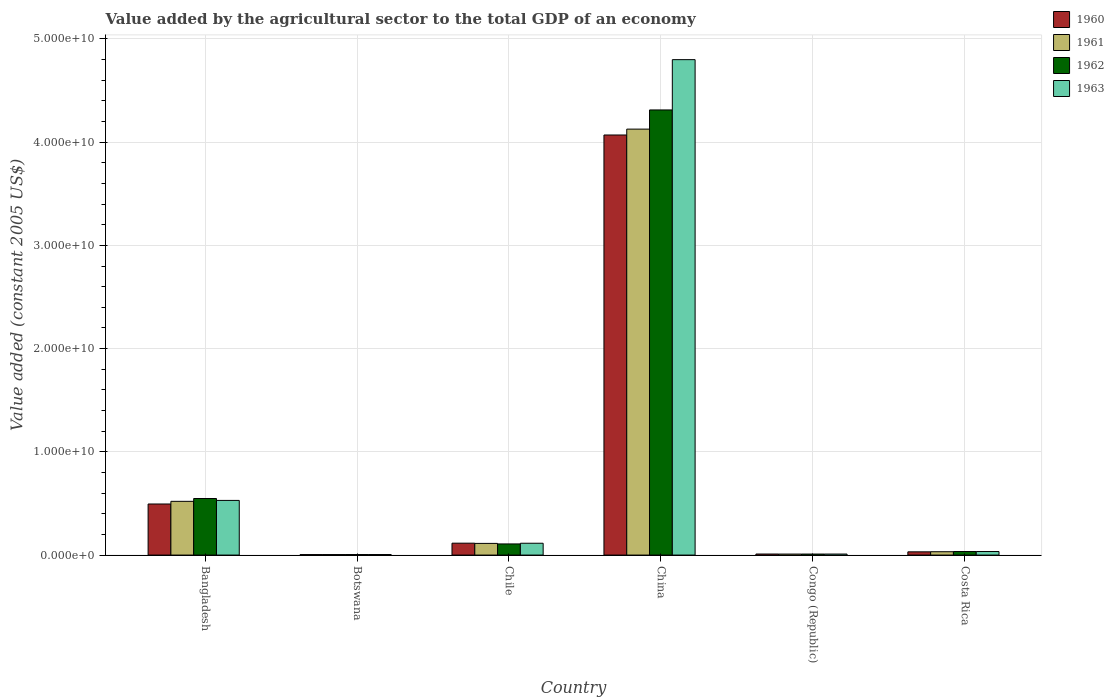How many different coloured bars are there?
Provide a succinct answer. 4. How many groups of bars are there?
Provide a short and direct response. 6. How many bars are there on the 2nd tick from the left?
Offer a terse response. 4. In how many cases, is the number of bars for a given country not equal to the number of legend labels?
Offer a very short reply. 0. What is the value added by the agricultural sector in 1963 in Costa Rica?
Offer a very short reply. 3.43e+08. Across all countries, what is the maximum value added by the agricultural sector in 1961?
Provide a succinct answer. 4.13e+1. Across all countries, what is the minimum value added by the agricultural sector in 1960?
Provide a short and direct response. 4.74e+07. In which country was the value added by the agricultural sector in 1960 maximum?
Give a very brief answer. China. In which country was the value added by the agricultural sector in 1960 minimum?
Ensure brevity in your answer.  Botswana. What is the total value added by the agricultural sector in 1961 in the graph?
Give a very brief answer. 4.81e+1. What is the difference between the value added by the agricultural sector in 1962 in Botswana and that in China?
Keep it short and to the point. -4.31e+1. What is the difference between the value added by the agricultural sector in 1960 in Congo (Republic) and the value added by the agricultural sector in 1961 in Botswana?
Offer a very short reply. 5.23e+07. What is the average value added by the agricultural sector in 1963 per country?
Offer a terse response. 9.16e+09. What is the difference between the value added by the agricultural sector of/in 1961 and value added by the agricultural sector of/in 1962 in China?
Your answer should be compact. -1.86e+09. In how many countries, is the value added by the agricultural sector in 1960 greater than 4000000000 US$?
Give a very brief answer. 2. What is the ratio of the value added by the agricultural sector in 1962 in Bangladesh to that in Chile?
Keep it short and to the point. 5.08. Is the value added by the agricultural sector in 1961 in Botswana less than that in Congo (Republic)?
Give a very brief answer. Yes. What is the difference between the highest and the second highest value added by the agricultural sector in 1961?
Provide a short and direct response. -4.08e+09. What is the difference between the highest and the lowest value added by the agricultural sector in 1963?
Your answer should be compact. 4.79e+1. What does the 2nd bar from the left in Bangladesh represents?
Offer a very short reply. 1961. What does the 4th bar from the right in Congo (Republic) represents?
Provide a succinct answer. 1960. How many bars are there?
Keep it short and to the point. 24. What is the difference between two consecutive major ticks on the Y-axis?
Provide a short and direct response. 1.00e+1. Are the values on the major ticks of Y-axis written in scientific E-notation?
Offer a terse response. Yes. Does the graph contain any zero values?
Your answer should be very brief. No. Does the graph contain grids?
Your answer should be compact. Yes. How are the legend labels stacked?
Make the answer very short. Vertical. What is the title of the graph?
Your answer should be very brief. Value added by the agricultural sector to the total GDP of an economy. What is the label or title of the Y-axis?
Your answer should be compact. Value added (constant 2005 US$). What is the Value added (constant 2005 US$) in 1960 in Bangladesh?
Provide a succinct answer. 4.95e+09. What is the Value added (constant 2005 US$) of 1961 in Bangladesh?
Provide a succinct answer. 5.21e+09. What is the Value added (constant 2005 US$) of 1962 in Bangladesh?
Provide a short and direct response. 5.48e+09. What is the Value added (constant 2005 US$) in 1963 in Bangladesh?
Give a very brief answer. 5.30e+09. What is the Value added (constant 2005 US$) in 1960 in Botswana?
Give a very brief answer. 4.74e+07. What is the Value added (constant 2005 US$) in 1961 in Botswana?
Offer a very short reply. 4.86e+07. What is the Value added (constant 2005 US$) in 1962 in Botswana?
Give a very brief answer. 5.04e+07. What is the Value added (constant 2005 US$) of 1963 in Botswana?
Provide a short and direct response. 5.21e+07. What is the Value added (constant 2005 US$) of 1960 in Chile?
Your answer should be very brief. 1.15e+09. What is the Value added (constant 2005 US$) in 1961 in Chile?
Keep it short and to the point. 1.13e+09. What is the Value added (constant 2005 US$) in 1962 in Chile?
Provide a short and direct response. 1.08e+09. What is the Value added (constant 2005 US$) of 1963 in Chile?
Provide a succinct answer. 1.15e+09. What is the Value added (constant 2005 US$) of 1960 in China?
Offer a very short reply. 4.07e+1. What is the Value added (constant 2005 US$) in 1961 in China?
Offer a very short reply. 4.13e+1. What is the Value added (constant 2005 US$) of 1962 in China?
Give a very brief answer. 4.31e+1. What is the Value added (constant 2005 US$) in 1963 in China?
Offer a very short reply. 4.80e+1. What is the Value added (constant 2005 US$) of 1960 in Congo (Republic)?
Your answer should be very brief. 1.01e+08. What is the Value added (constant 2005 US$) in 1961 in Congo (Republic)?
Ensure brevity in your answer.  9.74e+07. What is the Value added (constant 2005 US$) of 1962 in Congo (Republic)?
Offer a terse response. 9.79e+07. What is the Value added (constant 2005 US$) in 1963 in Congo (Republic)?
Ensure brevity in your answer.  9.86e+07. What is the Value added (constant 2005 US$) in 1960 in Costa Rica?
Offer a very short reply. 3.13e+08. What is the Value added (constant 2005 US$) of 1961 in Costa Rica?
Provide a short and direct response. 3.24e+08. What is the Value added (constant 2005 US$) in 1962 in Costa Rica?
Your response must be concise. 3.44e+08. What is the Value added (constant 2005 US$) in 1963 in Costa Rica?
Your answer should be compact. 3.43e+08. Across all countries, what is the maximum Value added (constant 2005 US$) in 1960?
Offer a terse response. 4.07e+1. Across all countries, what is the maximum Value added (constant 2005 US$) of 1961?
Provide a succinct answer. 4.13e+1. Across all countries, what is the maximum Value added (constant 2005 US$) in 1962?
Provide a short and direct response. 4.31e+1. Across all countries, what is the maximum Value added (constant 2005 US$) in 1963?
Offer a terse response. 4.80e+1. Across all countries, what is the minimum Value added (constant 2005 US$) of 1960?
Your answer should be very brief. 4.74e+07. Across all countries, what is the minimum Value added (constant 2005 US$) in 1961?
Your answer should be compact. 4.86e+07. Across all countries, what is the minimum Value added (constant 2005 US$) of 1962?
Ensure brevity in your answer.  5.04e+07. Across all countries, what is the minimum Value added (constant 2005 US$) of 1963?
Make the answer very short. 5.21e+07. What is the total Value added (constant 2005 US$) in 1960 in the graph?
Offer a very short reply. 4.73e+1. What is the total Value added (constant 2005 US$) of 1961 in the graph?
Provide a succinct answer. 4.81e+1. What is the total Value added (constant 2005 US$) of 1962 in the graph?
Provide a short and direct response. 5.02e+1. What is the total Value added (constant 2005 US$) in 1963 in the graph?
Your response must be concise. 5.49e+1. What is the difference between the Value added (constant 2005 US$) in 1960 in Bangladesh and that in Botswana?
Provide a short and direct response. 4.90e+09. What is the difference between the Value added (constant 2005 US$) of 1961 in Bangladesh and that in Botswana?
Make the answer very short. 5.16e+09. What is the difference between the Value added (constant 2005 US$) of 1962 in Bangladesh and that in Botswana?
Offer a terse response. 5.43e+09. What is the difference between the Value added (constant 2005 US$) of 1963 in Bangladesh and that in Botswana?
Provide a succinct answer. 5.24e+09. What is the difference between the Value added (constant 2005 US$) of 1960 in Bangladesh and that in Chile?
Your response must be concise. 3.80e+09. What is the difference between the Value added (constant 2005 US$) in 1961 in Bangladesh and that in Chile?
Your answer should be compact. 4.08e+09. What is the difference between the Value added (constant 2005 US$) in 1962 in Bangladesh and that in Chile?
Your answer should be compact. 4.40e+09. What is the difference between the Value added (constant 2005 US$) of 1963 in Bangladesh and that in Chile?
Make the answer very short. 4.15e+09. What is the difference between the Value added (constant 2005 US$) in 1960 in Bangladesh and that in China?
Provide a short and direct response. -3.57e+1. What is the difference between the Value added (constant 2005 US$) of 1961 in Bangladesh and that in China?
Keep it short and to the point. -3.61e+1. What is the difference between the Value added (constant 2005 US$) of 1962 in Bangladesh and that in China?
Your response must be concise. -3.76e+1. What is the difference between the Value added (constant 2005 US$) in 1963 in Bangladesh and that in China?
Give a very brief answer. -4.27e+1. What is the difference between the Value added (constant 2005 US$) in 1960 in Bangladesh and that in Congo (Republic)?
Give a very brief answer. 4.85e+09. What is the difference between the Value added (constant 2005 US$) in 1961 in Bangladesh and that in Congo (Republic)?
Provide a succinct answer. 5.11e+09. What is the difference between the Value added (constant 2005 US$) of 1962 in Bangladesh and that in Congo (Republic)?
Keep it short and to the point. 5.38e+09. What is the difference between the Value added (constant 2005 US$) in 1963 in Bangladesh and that in Congo (Republic)?
Ensure brevity in your answer.  5.20e+09. What is the difference between the Value added (constant 2005 US$) in 1960 in Bangladesh and that in Costa Rica?
Provide a short and direct response. 4.64e+09. What is the difference between the Value added (constant 2005 US$) of 1961 in Bangladesh and that in Costa Rica?
Offer a very short reply. 4.88e+09. What is the difference between the Value added (constant 2005 US$) of 1962 in Bangladesh and that in Costa Rica?
Offer a very short reply. 5.14e+09. What is the difference between the Value added (constant 2005 US$) in 1963 in Bangladesh and that in Costa Rica?
Give a very brief answer. 4.95e+09. What is the difference between the Value added (constant 2005 US$) of 1960 in Botswana and that in Chile?
Your response must be concise. -1.10e+09. What is the difference between the Value added (constant 2005 US$) of 1961 in Botswana and that in Chile?
Your answer should be compact. -1.08e+09. What is the difference between the Value added (constant 2005 US$) of 1962 in Botswana and that in Chile?
Your answer should be compact. -1.03e+09. What is the difference between the Value added (constant 2005 US$) in 1963 in Botswana and that in Chile?
Ensure brevity in your answer.  -1.09e+09. What is the difference between the Value added (constant 2005 US$) of 1960 in Botswana and that in China?
Provide a short and direct response. -4.07e+1. What is the difference between the Value added (constant 2005 US$) of 1961 in Botswana and that in China?
Give a very brief answer. -4.12e+1. What is the difference between the Value added (constant 2005 US$) of 1962 in Botswana and that in China?
Your answer should be compact. -4.31e+1. What is the difference between the Value added (constant 2005 US$) in 1963 in Botswana and that in China?
Your answer should be compact. -4.79e+1. What is the difference between the Value added (constant 2005 US$) in 1960 in Botswana and that in Congo (Republic)?
Give a very brief answer. -5.35e+07. What is the difference between the Value added (constant 2005 US$) in 1961 in Botswana and that in Congo (Republic)?
Provide a succinct answer. -4.87e+07. What is the difference between the Value added (constant 2005 US$) of 1962 in Botswana and that in Congo (Republic)?
Ensure brevity in your answer.  -4.76e+07. What is the difference between the Value added (constant 2005 US$) in 1963 in Botswana and that in Congo (Republic)?
Your answer should be compact. -4.65e+07. What is the difference between the Value added (constant 2005 US$) in 1960 in Botswana and that in Costa Rica?
Make the answer very short. -2.66e+08. What is the difference between the Value added (constant 2005 US$) of 1961 in Botswana and that in Costa Rica?
Provide a short and direct response. -2.76e+08. What is the difference between the Value added (constant 2005 US$) of 1962 in Botswana and that in Costa Rica?
Your answer should be compact. -2.94e+08. What is the difference between the Value added (constant 2005 US$) in 1963 in Botswana and that in Costa Rica?
Keep it short and to the point. -2.91e+08. What is the difference between the Value added (constant 2005 US$) in 1960 in Chile and that in China?
Your response must be concise. -3.95e+1. What is the difference between the Value added (constant 2005 US$) in 1961 in Chile and that in China?
Offer a very short reply. -4.01e+1. What is the difference between the Value added (constant 2005 US$) of 1962 in Chile and that in China?
Provide a short and direct response. -4.20e+1. What is the difference between the Value added (constant 2005 US$) of 1963 in Chile and that in China?
Offer a very short reply. -4.69e+1. What is the difference between the Value added (constant 2005 US$) in 1960 in Chile and that in Congo (Republic)?
Your answer should be very brief. 1.05e+09. What is the difference between the Value added (constant 2005 US$) in 1961 in Chile and that in Congo (Republic)?
Offer a terse response. 1.03e+09. What is the difference between the Value added (constant 2005 US$) of 1962 in Chile and that in Congo (Republic)?
Offer a very short reply. 9.81e+08. What is the difference between the Value added (constant 2005 US$) of 1963 in Chile and that in Congo (Republic)?
Provide a succinct answer. 1.05e+09. What is the difference between the Value added (constant 2005 US$) in 1960 in Chile and that in Costa Rica?
Offer a terse response. 8.39e+08. What is the difference between the Value added (constant 2005 US$) of 1961 in Chile and that in Costa Rica?
Your answer should be compact. 8.06e+08. What is the difference between the Value added (constant 2005 US$) of 1962 in Chile and that in Costa Rica?
Ensure brevity in your answer.  7.35e+08. What is the difference between the Value added (constant 2005 US$) of 1963 in Chile and that in Costa Rica?
Your answer should be very brief. 8.03e+08. What is the difference between the Value added (constant 2005 US$) in 1960 in China and that in Congo (Republic)?
Keep it short and to the point. 4.06e+1. What is the difference between the Value added (constant 2005 US$) of 1961 in China and that in Congo (Republic)?
Offer a terse response. 4.12e+1. What is the difference between the Value added (constant 2005 US$) in 1962 in China and that in Congo (Republic)?
Make the answer very short. 4.30e+1. What is the difference between the Value added (constant 2005 US$) in 1963 in China and that in Congo (Republic)?
Offer a very short reply. 4.79e+1. What is the difference between the Value added (constant 2005 US$) of 1960 in China and that in Costa Rica?
Your response must be concise. 4.04e+1. What is the difference between the Value added (constant 2005 US$) of 1961 in China and that in Costa Rica?
Offer a terse response. 4.09e+1. What is the difference between the Value added (constant 2005 US$) of 1962 in China and that in Costa Rica?
Your answer should be very brief. 4.28e+1. What is the difference between the Value added (constant 2005 US$) in 1963 in China and that in Costa Rica?
Your response must be concise. 4.77e+1. What is the difference between the Value added (constant 2005 US$) in 1960 in Congo (Republic) and that in Costa Rica?
Your answer should be very brief. -2.12e+08. What is the difference between the Value added (constant 2005 US$) in 1961 in Congo (Republic) and that in Costa Rica?
Offer a terse response. -2.27e+08. What is the difference between the Value added (constant 2005 US$) in 1962 in Congo (Republic) and that in Costa Rica?
Your response must be concise. -2.46e+08. What is the difference between the Value added (constant 2005 US$) of 1963 in Congo (Republic) and that in Costa Rica?
Offer a terse response. -2.45e+08. What is the difference between the Value added (constant 2005 US$) of 1960 in Bangladesh and the Value added (constant 2005 US$) of 1961 in Botswana?
Your answer should be compact. 4.90e+09. What is the difference between the Value added (constant 2005 US$) in 1960 in Bangladesh and the Value added (constant 2005 US$) in 1962 in Botswana?
Ensure brevity in your answer.  4.90e+09. What is the difference between the Value added (constant 2005 US$) of 1960 in Bangladesh and the Value added (constant 2005 US$) of 1963 in Botswana?
Keep it short and to the point. 4.90e+09. What is the difference between the Value added (constant 2005 US$) in 1961 in Bangladesh and the Value added (constant 2005 US$) in 1962 in Botswana?
Provide a succinct answer. 5.16e+09. What is the difference between the Value added (constant 2005 US$) in 1961 in Bangladesh and the Value added (constant 2005 US$) in 1963 in Botswana?
Provide a short and direct response. 5.15e+09. What is the difference between the Value added (constant 2005 US$) of 1962 in Bangladesh and the Value added (constant 2005 US$) of 1963 in Botswana?
Your response must be concise. 5.43e+09. What is the difference between the Value added (constant 2005 US$) of 1960 in Bangladesh and the Value added (constant 2005 US$) of 1961 in Chile?
Make the answer very short. 3.82e+09. What is the difference between the Value added (constant 2005 US$) in 1960 in Bangladesh and the Value added (constant 2005 US$) in 1962 in Chile?
Offer a very short reply. 3.87e+09. What is the difference between the Value added (constant 2005 US$) of 1960 in Bangladesh and the Value added (constant 2005 US$) of 1963 in Chile?
Your answer should be very brief. 3.80e+09. What is the difference between the Value added (constant 2005 US$) in 1961 in Bangladesh and the Value added (constant 2005 US$) in 1962 in Chile?
Offer a very short reply. 4.13e+09. What is the difference between the Value added (constant 2005 US$) of 1961 in Bangladesh and the Value added (constant 2005 US$) of 1963 in Chile?
Ensure brevity in your answer.  4.06e+09. What is the difference between the Value added (constant 2005 US$) in 1962 in Bangladesh and the Value added (constant 2005 US$) in 1963 in Chile?
Provide a succinct answer. 4.33e+09. What is the difference between the Value added (constant 2005 US$) in 1960 in Bangladesh and the Value added (constant 2005 US$) in 1961 in China?
Make the answer very short. -3.63e+1. What is the difference between the Value added (constant 2005 US$) of 1960 in Bangladesh and the Value added (constant 2005 US$) of 1962 in China?
Ensure brevity in your answer.  -3.82e+1. What is the difference between the Value added (constant 2005 US$) in 1960 in Bangladesh and the Value added (constant 2005 US$) in 1963 in China?
Offer a very short reply. -4.30e+1. What is the difference between the Value added (constant 2005 US$) in 1961 in Bangladesh and the Value added (constant 2005 US$) in 1962 in China?
Offer a very short reply. -3.79e+1. What is the difference between the Value added (constant 2005 US$) of 1961 in Bangladesh and the Value added (constant 2005 US$) of 1963 in China?
Offer a terse response. -4.28e+1. What is the difference between the Value added (constant 2005 US$) in 1962 in Bangladesh and the Value added (constant 2005 US$) in 1963 in China?
Offer a terse response. -4.25e+1. What is the difference between the Value added (constant 2005 US$) in 1960 in Bangladesh and the Value added (constant 2005 US$) in 1961 in Congo (Republic)?
Ensure brevity in your answer.  4.85e+09. What is the difference between the Value added (constant 2005 US$) in 1960 in Bangladesh and the Value added (constant 2005 US$) in 1962 in Congo (Republic)?
Your response must be concise. 4.85e+09. What is the difference between the Value added (constant 2005 US$) in 1960 in Bangladesh and the Value added (constant 2005 US$) in 1963 in Congo (Republic)?
Provide a succinct answer. 4.85e+09. What is the difference between the Value added (constant 2005 US$) of 1961 in Bangladesh and the Value added (constant 2005 US$) of 1962 in Congo (Republic)?
Your answer should be compact. 5.11e+09. What is the difference between the Value added (constant 2005 US$) of 1961 in Bangladesh and the Value added (constant 2005 US$) of 1963 in Congo (Republic)?
Ensure brevity in your answer.  5.11e+09. What is the difference between the Value added (constant 2005 US$) of 1962 in Bangladesh and the Value added (constant 2005 US$) of 1963 in Congo (Republic)?
Ensure brevity in your answer.  5.38e+09. What is the difference between the Value added (constant 2005 US$) in 1960 in Bangladesh and the Value added (constant 2005 US$) in 1961 in Costa Rica?
Ensure brevity in your answer.  4.62e+09. What is the difference between the Value added (constant 2005 US$) in 1960 in Bangladesh and the Value added (constant 2005 US$) in 1962 in Costa Rica?
Your answer should be very brief. 4.60e+09. What is the difference between the Value added (constant 2005 US$) of 1960 in Bangladesh and the Value added (constant 2005 US$) of 1963 in Costa Rica?
Give a very brief answer. 4.61e+09. What is the difference between the Value added (constant 2005 US$) of 1961 in Bangladesh and the Value added (constant 2005 US$) of 1962 in Costa Rica?
Offer a very short reply. 4.86e+09. What is the difference between the Value added (constant 2005 US$) in 1961 in Bangladesh and the Value added (constant 2005 US$) in 1963 in Costa Rica?
Offer a very short reply. 4.86e+09. What is the difference between the Value added (constant 2005 US$) in 1962 in Bangladesh and the Value added (constant 2005 US$) in 1963 in Costa Rica?
Offer a terse response. 5.14e+09. What is the difference between the Value added (constant 2005 US$) of 1960 in Botswana and the Value added (constant 2005 US$) of 1961 in Chile?
Give a very brief answer. -1.08e+09. What is the difference between the Value added (constant 2005 US$) in 1960 in Botswana and the Value added (constant 2005 US$) in 1962 in Chile?
Ensure brevity in your answer.  -1.03e+09. What is the difference between the Value added (constant 2005 US$) of 1960 in Botswana and the Value added (constant 2005 US$) of 1963 in Chile?
Provide a succinct answer. -1.10e+09. What is the difference between the Value added (constant 2005 US$) in 1961 in Botswana and the Value added (constant 2005 US$) in 1962 in Chile?
Offer a very short reply. -1.03e+09. What is the difference between the Value added (constant 2005 US$) in 1961 in Botswana and the Value added (constant 2005 US$) in 1963 in Chile?
Make the answer very short. -1.10e+09. What is the difference between the Value added (constant 2005 US$) of 1962 in Botswana and the Value added (constant 2005 US$) of 1963 in Chile?
Provide a succinct answer. -1.10e+09. What is the difference between the Value added (constant 2005 US$) of 1960 in Botswana and the Value added (constant 2005 US$) of 1961 in China?
Keep it short and to the point. -4.12e+1. What is the difference between the Value added (constant 2005 US$) of 1960 in Botswana and the Value added (constant 2005 US$) of 1962 in China?
Make the answer very short. -4.31e+1. What is the difference between the Value added (constant 2005 US$) in 1960 in Botswana and the Value added (constant 2005 US$) in 1963 in China?
Your answer should be compact. -4.80e+1. What is the difference between the Value added (constant 2005 US$) of 1961 in Botswana and the Value added (constant 2005 US$) of 1962 in China?
Provide a short and direct response. -4.31e+1. What is the difference between the Value added (constant 2005 US$) in 1961 in Botswana and the Value added (constant 2005 US$) in 1963 in China?
Your answer should be compact. -4.79e+1. What is the difference between the Value added (constant 2005 US$) of 1962 in Botswana and the Value added (constant 2005 US$) of 1963 in China?
Your answer should be compact. -4.79e+1. What is the difference between the Value added (constant 2005 US$) of 1960 in Botswana and the Value added (constant 2005 US$) of 1961 in Congo (Republic)?
Make the answer very short. -4.99e+07. What is the difference between the Value added (constant 2005 US$) of 1960 in Botswana and the Value added (constant 2005 US$) of 1962 in Congo (Republic)?
Your answer should be very brief. -5.05e+07. What is the difference between the Value added (constant 2005 US$) in 1960 in Botswana and the Value added (constant 2005 US$) in 1963 in Congo (Republic)?
Offer a very short reply. -5.12e+07. What is the difference between the Value added (constant 2005 US$) in 1961 in Botswana and the Value added (constant 2005 US$) in 1962 in Congo (Republic)?
Your answer should be compact. -4.93e+07. What is the difference between the Value added (constant 2005 US$) of 1961 in Botswana and the Value added (constant 2005 US$) of 1963 in Congo (Republic)?
Make the answer very short. -5.00e+07. What is the difference between the Value added (constant 2005 US$) of 1962 in Botswana and the Value added (constant 2005 US$) of 1963 in Congo (Republic)?
Ensure brevity in your answer.  -4.83e+07. What is the difference between the Value added (constant 2005 US$) in 1960 in Botswana and the Value added (constant 2005 US$) in 1961 in Costa Rica?
Give a very brief answer. -2.77e+08. What is the difference between the Value added (constant 2005 US$) in 1960 in Botswana and the Value added (constant 2005 US$) in 1962 in Costa Rica?
Give a very brief answer. -2.97e+08. What is the difference between the Value added (constant 2005 US$) in 1960 in Botswana and the Value added (constant 2005 US$) in 1963 in Costa Rica?
Your answer should be very brief. -2.96e+08. What is the difference between the Value added (constant 2005 US$) of 1961 in Botswana and the Value added (constant 2005 US$) of 1962 in Costa Rica?
Provide a succinct answer. -2.96e+08. What is the difference between the Value added (constant 2005 US$) of 1961 in Botswana and the Value added (constant 2005 US$) of 1963 in Costa Rica?
Provide a short and direct response. -2.95e+08. What is the difference between the Value added (constant 2005 US$) in 1962 in Botswana and the Value added (constant 2005 US$) in 1963 in Costa Rica?
Keep it short and to the point. -2.93e+08. What is the difference between the Value added (constant 2005 US$) of 1960 in Chile and the Value added (constant 2005 US$) of 1961 in China?
Offer a very short reply. -4.01e+1. What is the difference between the Value added (constant 2005 US$) of 1960 in Chile and the Value added (constant 2005 US$) of 1962 in China?
Offer a terse response. -4.20e+1. What is the difference between the Value added (constant 2005 US$) in 1960 in Chile and the Value added (constant 2005 US$) in 1963 in China?
Keep it short and to the point. -4.68e+1. What is the difference between the Value added (constant 2005 US$) of 1961 in Chile and the Value added (constant 2005 US$) of 1962 in China?
Provide a succinct answer. -4.20e+1. What is the difference between the Value added (constant 2005 US$) of 1961 in Chile and the Value added (constant 2005 US$) of 1963 in China?
Your answer should be very brief. -4.69e+1. What is the difference between the Value added (constant 2005 US$) of 1962 in Chile and the Value added (constant 2005 US$) of 1963 in China?
Offer a terse response. -4.69e+1. What is the difference between the Value added (constant 2005 US$) of 1960 in Chile and the Value added (constant 2005 US$) of 1961 in Congo (Republic)?
Provide a short and direct response. 1.05e+09. What is the difference between the Value added (constant 2005 US$) in 1960 in Chile and the Value added (constant 2005 US$) in 1962 in Congo (Republic)?
Make the answer very short. 1.05e+09. What is the difference between the Value added (constant 2005 US$) of 1960 in Chile and the Value added (constant 2005 US$) of 1963 in Congo (Republic)?
Your answer should be compact. 1.05e+09. What is the difference between the Value added (constant 2005 US$) of 1961 in Chile and the Value added (constant 2005 US$) of 1962 in Congo (Republic)?
Your answer should be compact. 1.03e+09. What is the difference between the Value added (constant 2005 US$) of 1961 in Chile and the Value added (constant 2005 US$) of 1963 in Congo (Republic)?
Provide a short and direct response. 1.03e+09. What is the difference between the Value added (constant 2005 US$) in 1962 in Chile and the Value added (constant 2005 US$) in 1963 in Congo (Republic)?
Give a very brief answer. 9.81e+08. What is the difference between the Value added (constant 2005 US$) in 1960 in Chile and the Value added (constant 2005 US$) in 1961 in Costa Rica?
Your answer should be very brief. 8.27e+08. What is the difference between the Value added (constant 2005 US$) of 1960 in Chile and the Value added (constant 2005 US$) of 1962 in Costa Rica?
Give a very brief answer. 8.07e+08. What is the difference between the Value added (constant 2005 US$) in 1960 in Chile and the Value added (constant 2005 US$) in 1963 in Costa Rica?
Offer a terse response. 8.08e+08. What is the difference between the Value added (constant 2005 US$) in 1961 in Chile and the Value added (constant 2005 US$) in 1962 in Costa Rica?
Your answer should be very brief. 7.86e+08. What is the difference between the Value added (constant 2005 US$) in 1961 in Chile and the Value added (constant 2005 US$) in 1963 in Costa Rica?
Your answer should be compact. 7.87e+08. What is the difference between the Value added (constant 2005 US$) in 1962 in Chile and the Value added (constant 2005 US$) in 1963 in Costa Rica?
Offer a terse response. 7.36e+08. What is the difference between the Value added (constant 2005 US$) in 1960 in China and the Value added (constant 2005 US$) in 1961 in Congo (Republic)?
Provide a short and direct response. 4.06e+1. What is the difference between the Value added (constant 2005 US$) of 1960 in China and the Value added (constant 2005 US$) of 1962 in Congo (Republic)?
Offer a terse response. 4.06e+1. What is the difference between the Value added (constant 2005 US$) in 1960 in China and the Value added (constant 2005 US$) in 1963 in Congo (Republic)?
Make the answer very short. 4.06e+1. What is the difference between the Value added (constant 2005 US$) in 1961 in China and the Value added (constant 2005 US$) in 1962 in Congo (Republic)?
Offer a very short reply. 4.12e+1. What is the difference between the Value added (constant 2005 US$) in 1961 in China and the Value added (constant 2005 US$) in 1963 in Congo (Republic)?
Your response must be concise. 4.12e+1. What is the difference between the Value added (constant 2005 US$) in 1962 in China and the Value added (constant 2005 US$) in 1963 in Congo (Republic)?
Offer a terse response. 4.30e+1. What is the difference between the Value added (constant 2005 US$) of 1960 in China and the Value added (constant 2005 US$) of 1961 in Costa Rica?
Your answer should be compact. 4.04e+1. What is the difference between the Value added (constant 2005 US$) in 1960 in China and the Value added (constant 2005 US$) in 1962 in Costa Rica?
Your answer should be very brief. 4.04e+1. What is the difference between the Value added (constant 2005 US$) of 1960 in China and the Value added (constant 2005 US$) of 1963 in Costa Rica?
Ensure brevity in your answer.  4.04e+1. What is the difference between the Value added (constant 2005 US$) of 1961 in China and the Value added (constant 2005 US$) of 1962 in Costa Rica?
Ensure brevity in your answer.  4.09e+1. What is the difference between the Value added (constant 2005 US$) in 1961 in China and the Value added (constant 2005 US$) in 1963 in Costa Rica?
Your response must be concise. 4.09e+1. What is the difference between the Value added (constant 2005 US$) in 1962 in China and the Value added (constant 2005 US$) in 1963 in Costa Rica?
Give a very brief answer. 4.28e+1. What is the difference between the Value added (constant 2005 US$) of 1960 in Congo (Republic) and the Value added (constant 2005 US$) of 1961 in Costa Rica?
Keep it short and to the point. -2.24e+08. What is the difference between the Value added (constant 2005 US$) of 1960 in Congo (Republic) and the Value added (constant 2005 US$) of 1962 in Costa Rica?
Offer a very short reply. -2.43e+08. What is the difference between the Value added (constant 2005 US$) in 1960 in Congo (Republic) and the Value added (constant 2005 US$) in 1963 in Costa Rica?
Give a very brief answer. -2.42e+08. What is the difference between the Value added (constant 2005 US$) of 1961 in Congo (Republic) and the Value added (constant 2005 US$) of 1962 in Costa Rica?
Your answer should be very brief. -2.47e+08. What is the difference between the Value added (constant 2005 US$) in 1961 in Congo (Republic) and the Value added (constant 2005 US$) in 1963 in Costa Rica?
Keep it short and to the point. -2.46e+08. What is the difference between the Value added (constant 2005 US$) in 1962 in Congo (Republic) and the Value added (constant 2005 US$) in 1963 in Costa Rica?
Make the answer very short. -2.45e+08. What is the average Value added (constant 2005 US$) of 1960 per country?
Offer a very short reply. 7.88e+09. What is the average Value added (constant 2005 US$) of 1961 per country?
Give a very brief answer. 8.01e+09. What is the average Value added (constant 2005 US$) of 1962 per country?
Provide a succinct answer. 8.36e+09. What is the average Value added (constant 2005 US$) of 1963 per country?
Your answer should be very brief. 9.16e+09. What is the difference between the Value added (constant 2005 US$) in 1960 and Value added (constant 2005 US$) in 1961 in Bangladesh?
Offer a terse response. -2.58e+08. What is the difference between the Value added (constant 2005 US$) of 1960 and Value added (constant 2005 US$) of 1962 in Bangladesh?
Make the answer very short. -5.31e+08. What is the difference between the Value added (constant 2005 US$) of 1960 and Value added (constant 2005 US$) of 1963 in Bangladesh?
Ensure brevity in your answer.  -3.47e+08. What is the difference between the Value added (constant 2005 US$) of 1961 and Value added (constant 2005 US$) of 1962 in Bangladesh?
Ensure brevity in your answer.  -2.73e+08. What is the difference between the Value added (constant 2005 US$) in 1961 and Value added (constant 2005 US$) in 1963 in Bangladesh?
Your response must be concise. -8.88e+07. What is the difference between the Value added (constant 2005 US$) in 1962 and Value added (constant 2005 US$) in 1963 in Bangladesh?
Keep it short and to the point. 1.84e+08. What is the difference between the Value added (constant 2005 US$) in 1960 and Value added (constant 2005 US$) in 1961 in Botswana?
Your answer should be very brief. -1.17e+06. What is the difference between the Value added (constant 2005 US$) in 1960 and Value added (constant 2005 US$) in 1962 in Botswana?
Keep it short and to the point. -2.92e+06. What is the difference between the Value added (constant 2005 US$) in 1960 and Value added (constant 2005 US$) in 1963 in Botswana?
Give a very brief answer. -4.67e+06. What is the difference between the Value added (constant 2005 US$) of 1961 and Value added (constant 2005 US$) of 1962 in Botswana?
Keep it short and to the point. -1.75e+06. What is the difference between the Value added (constant 2005 US$) of 1961 and Value added (constant 2005 US$) of 1963 in Botswana?
Offer a terse response. -3.51e+06. What is the difference between the Value added (constant 2005 US$) of 1962 and Value added (constant 2005 US$) of 1963 in Botswana?
Give a very brief answer. -1.75e+06. What is the difference between the Value added (constant 2005 US$) of 1960 and Value added (constant 2005 US$) of 1961 in Chile?
Provide a short and direct response. 2.12e+07. What is the difference between the Value added (constant 2005 US$) in 1960 and Value added (constant 2005 US$) in 1962 in Chile?
Offer a terse response. 7.27e+07. What is the difference between the Value added (constant 2005 US$) in 1960 and Value added (constant 2005 US$) in 1963 in Chile?
Give a very brief answer. 5.74e+06. What is the difference between the Value added (constant 2005 US$) in 1961 and Value added (constant 2005 US$) in 1962 in Chile?
Ensure brevity in your answer.  5.15e+07. What is the difference between the Value added (constant 2005 US$) of 1961 and Value added (constant 2005 US$) of 1963 in Chile?
Provide a short and direct response. -1.54e+07. What is the difference between the Value added (constant 2005 US$) in 1962 and Value added (constant 2005 US$) in 1963 in Chile?
Keep it short and to the point. -6.69e+07. What is the difference between the Value added (constant 2005 US$) in 1960 and Value added (constant 2005 US$) in 1961 in China?
Your answer should be compact. -5.70e+08. What is the difference between the Value added (constant 2005 US$) in 1960 and Value added (constant 2005 US$) in 1962 in China?
Keep it short and to the point. -2.43e+09. What is the difference between the Value added (constant 2005 US$) in 1960 and Value added (constant 2005 US$) in 1963 in China?
Offer a terse response. -7.30e+09. What is the difference between the Value added (constant 2005 US$) in 1961 and Value added (constant 2005 US$) in 1962 in China?
Ensure brevity in your answer.  -1.86e+09. What is the difference between the Value added (constant 2005 US$) of 1961 and Value added (constant 2005 US$) of 1963 in China?
Your answer should be very brief. -6.73e+09. What is the difference between the Value added (constant 2005 US$) of 1962 and Value added (constant 2005 US$) of 1963 in China?
Your response must be concise. -4.87e+09. What is the difference between the Value added (constant 2005 US$) in 1960 and Value added (constant 2005 US$) in 1961 in Congo (Republic)?
Your answer should be compact. 3.61e+06. What is the difference between the Value added (constant 2005 US$) of 1960 and Value added (constant 2005 US$) of 1962 in Congo (Republic)?
Offer a terse response. 3.02e+06. What is the difference between the Value added (constant 2005 US$) of 1960 and Value added (constant 2005 US$) of 1963 in Congo (Republic)?
Make the answer very short. 2.34e+06. What is the difference between the Value added (constant 2005 US$) of 1961 and Value added (constant 2005 US$) of 1962 in Congo (Republic)?
Ensure brevity in your answer.  -5.86e+05. What is the difference between the Value added (constant 2005 US$) of 1961 and Value added (constant 2005 US$) of 1963 in Congo (Republic)?
Your answer should be compact. -1.27e+06. What is the difference between the Value added (constant 2005 US$) in 1962 and Value added (constant 2005 US$) in 1963 in Congo (Republic)?
Your answer should be very brief. -6.85e+05. What is the difference between the Value added (constant 2005 US$) in 1960 and Value added (constant 2005 US$) in 1961 in Costa Rica?
Your answer should be compact. -1.15e+07. What is the difference between the Value added (constant 2005 US$) of 1960 and Value added (constant 2005 US$) of 1962 in Costa Rica?
Provide a succinct answer. -3.14e+07. What is the difference between the Value added (constant 2005 US$) in 1960 and Value added (constant 2005 US$) in 1963 in Costa Rica?
Offer a terse response. -3.04e+07. What is the difference between the Value added (constant 2005 US$) in 1961 and Value added (constant 2005 US$) in 1962 in Costa Rica?
Offer a very short reply. -1.99e+07. What is the difference between the Value added (constant 2005 US$) in 1961 and Value added (constant 2005 US$) in 1963 in Costa Rica?
Offer a very short reply. -1.89e+07. What is the difference between the Value added (constant 2005 US$) of 1962 and Value added (constant 2005 US$) of 1963 in Costa Rica?
Your response must be concise. 1.00e+06. What is the ratio of the Value added (constant 2005 US$) of 1960 in Bangladesh to that in Botswana?
Provide a short and direct response. 104.3. What is the ratio of the Value added (constant 2005 US$) in 1961 in Bangladesh to that in Botswana?
Keep it short and to the point. 107.09. What is the ratio of the Value added (constant 2005 US$) of 1962 in Bangladesh to that in Botswana?
Make the answer very short. 108.79. What is the ratio of the Value added (constant 2005 US$) of 1963 in Bangladesh to that in Botswana?
Ensure brevity in your answer.  101.59. What is the ratio of the Value added (constant 2005 US$) of 1960 in Bangladesh to that in Chile?
Provide a short and direct response. 4.3. What is the ratio of the Value added (constant 2005 US$) in 1961 in Bangladesh to that in Chile?
Ensure brevity in your answer.  4.6. What is the ratio of the Value added (constant 2005 US$) of 1962 in Bangladesh to that in Chile?
Your answer should be very brief. 5.08. What is the ratio of the Value added (constant 2005 US$) of 1963 in Bangladesh to that in Chile?
Offer a terse response. 4.62. What is the ratio of the Value added (constant 2005 US$) in 1960 in Bangladesh to that in China?
Make the answer very short. 0.12. What is the ratio of the Value added (constant 2005 US$) of 1961 in Bangladesh to that in China?
Offer a terse response. 0.13. What is the ratio of the Value added (constant 2005 US$) in 1962 in Bangladesh to that in China?
Provide a succinct answer. 0.13. What is the ratio of the Value added (constant 2005 US$) in 1963 in Bangladesh to that in China?
Offer a very short reply. 0.11. What is the ratio of the Value added (constant 2005 US$) in 1960 in Bangladesh to that in Congo (Republic)?
Keep it short and to the point. 49.02. What is the ratio of the Value added (constant 2005 US$) of 1961 in Bangladesh to that in Congo (Republic)?
Give a very brief answer. 53.48. What is the ratio of the Value added (constant 2005 US$) of 1962 in Bangladesh to that in Congo (Republic)?
Make the answer very short. 55.95. What is the ratio of the Value added (constant 2005 US$) in 1963 in Bangladesh to that in Congo (Republic)?
Provide a short and direct response. 53.69. What is the ratio of the Value added (constant 2005 US$) of 1960 in Bangladesh to that in Costa Rica?
Give a very brief answer. 15.81. What is the ratio of the Value added (constant 2005 US$) in 1961 in Bangladesh to that in Costa Rica?
Make the answer very short. 16.05. What is the ratio of the Value added (constant 2005 US$) in 1962 in Bangladesh to that in Costa Rica?
Your answer should be very brief. 15.91. What is the ratio of the Value added (constant 2005 US$) in 1963 in Bangladesh to that in Costa Rica?
Your answer should be compact. 15.42. What is the ratio of the Value added (constant 2005 US$) of 1960 in Botswana to that in Chile?
Make the answer very short. 0.04. What is the ratio of the Value added (constant 2005 US$) of 1961 in Botswana to that in Chile?
Keep it short and to the point. 0.04. What is the ratio of the Value added (constant 2005 US$) in 1962 in Botswana to that in Chile?
Offer a terse response. 0.05. What is the ratio of the Value added (constant 2005 US$) of 1963 in Botswana to that in Chile?
Give a very brief answer. 0.05. What is the ratio of the Value added (constant 2005 US$) of 1960 in Botswana to that in China?
Your response must be concise. 0. What is the ratio of the Value added (constant 2005 US$) of 1961 in Botswana to that in China?
Your answer should be compact. 0. What is the ratio of the Value added (constant 2005 US$) of 1962 in Botswana to that in China?
Make the answer very short. 0. What is the ratio of the Value added (constant 2005 US$) of 1963 in Botswana to that in China?
Ensure brevity in your answer.  0. What is the ratio of the Value added (constant 2005 US$) of 1960 in Botswana to that in Congo (Republic)?
Your answer should be compact. 0.47. What is the ratio of the Value added (constant 2005 US$) of 1961 in Botswana to that in Congo (Republic)?
Provide a short and direct response. 0.5. What is the ratio of the Value added (constant 2005 US$) in 1962 in Botswana to that in Congo (Republic)?
Offer a terse response. 0.51. What is the ratio of the Value added (constant 2005 US$) in 1963 in Botswana to that in Congo (Republic)?
Provide a succinct answer. 0.53. What is the ratio of the Value added (constant 2005 US$) of 1960 in Botswana to that in Costa Rica?
Keep it short and to the point. 0.15. What is the ratio of the Value added (constant 2005 US$) in 1961 in Botswana to that in Costa Rica?
Your answer should be very brief. 0.15. What is the ratio of the Value added (constant 2005 US$) in 1962 in Botswana to that in Costa Rica?
Make the answer very short. 0.15. What is the ratio of the Value added (constant 2005 US$) of 1963 in Botswana to that in Costa Rica?
Provide a short and direct response. 0.15. What is the ratio of the Value added (constant 2005 US$) of 1960 in Chile to that in China?
Your answer should be very brief. 0.03. What is the ratio of the Value added (constant 2005 US$) in 1961 in Chile to that in China?
Keep it short and to the point. 0.03. What is the ratio of the Value added (constant 2005 US$) of 1962 in Chile to that in China?
Offer a very short reply. 0.03. What is the ratio of the Value added (constant 2005 US$) in 1963 in Chile to that in China?
Your answer should be very brief. 0.02. What is the ratio of the Value added (constant 2005 US$) in 1960 in Chile to that in Congo (Republic)?
Your answer should be very brief. 11.41. What is the ratio of the Value added (constant 2005 US$) in 1961 in Chile to that in Congo (Republic)?
Your answer should be compact. 11.61. What is the ratio of the Value added (constant 2005 US$) of 1962 in Chile to that in Congo (Republic)?
Give a very brief answer. 11.02. What is the ratio of the Value added (constant 2005 US$) in 1963 in Chile to that in Congo (Republic)?
Keep it short and to the point. 11.62. What is the ratio of the Value added (constant 2005 US$) of 1960 in Chile to that in Costa Rica?
Give a very brief answer. 3.68. What is the ratio of the Value added (constant 2005 US$) in 1961 in Chile to that in Costa Rica?
Provide a succinct answer. 3.48. What is the ratio of the Value added (constant 2005 US$) of 1962 in Chile to that in Costa Rica?
Offer a very short reply. 3.13. What is the ratio of the Value added (constant 2005 US$) of 1963 in Chile to that in Costa Rica?
Keep it short and to the point. 3.34. What is the ratio of the Value added (constant 2005 US$) of 1960 in China to that in Congo (Republic)?
Your answer should be very brief. 403.12. What is the ratio of the Value added (constant 2005 US$) of 1961 in China to that in Congo (Republic)?
Your answer should be compact. 423.9. What is the ratio of the Value added (constant 2005 US$) of 1962 in China to that in Congo (Republic)?
Keep it short and to the point. 440.32. What is the ratio of the Value added (constant 2005 US$) of 1963 in China to that in Congo (Republic)?
Ensure brevity in your answer.  486.68. What is the ratio of the Value added (constant 2005 US$) of 1960 in China to that in Costa Rica?
Provide a short and direct response. 130.03. What is the ratio of the Value added (constant 2005 US$) in 1961 in China to that in Costa Rica?
Offer a very short reply. 127.18. What is the ratio of the Value added (constant 2005 US$) of 1962 in China to that in Costa Rica?
Offer a very short reply. 125.23. What is the ratio of the Value added (constant 2005 US$) in 1963 in China to that in Costa Rica?
Your answer should be very brief. 139.78. What is the ratio of the Value added (constant 2005 US$) of 1960 in Congo (Republic) to that in Costa Rica?
Offer a terse response. 0.32. What is the ratio of the Value added (constant 2005 US$) of 1962 in Congo (Republic) to that in Costa Rica?
Offer a terse response. 0.28. What is the ratio of the Value added (constant 2005 US$) of 1963 in Congo (Republic) to that in Costa Rica?
Offer a very short reply. 0.29. What is the difference between the highest and the second highest Value added (constant 2005 US$) in 1960?
Make the answer very short. 3.57e+1. What is the difference between the highest and the second highest Value added (constant 2005 US$) of 1961?
Provide a succinct answer. 3.61e+1. What is the difference between the highest and the second highest Value added (constant 2005 US$) in 1962?
Your response must be concise. 3.76e+1. What is the difference between the highest and the second highest Value added (constant 2005 US$) of 1963?
Give a very brief answer. 4.27e+1. What is the difference between the highest and the lowest Value added (constant 2005 US$) of 1960?
Your answer should be very brief. 4.07e+1. What is the difference between the highest and the lowest Value added (constant 2005 US$) of 1961?
Provide a succinct answer. 4.12e+1. What is the difference between the highest and the lowest Value added (constant 2005 US$) of 1962?
Offer a very short reply. 4.31e+1. What is the difference between the highest and the lowest Value added (constant 2005 US$) in 1963?
Provide a short and direct response. 4.79e+1. 